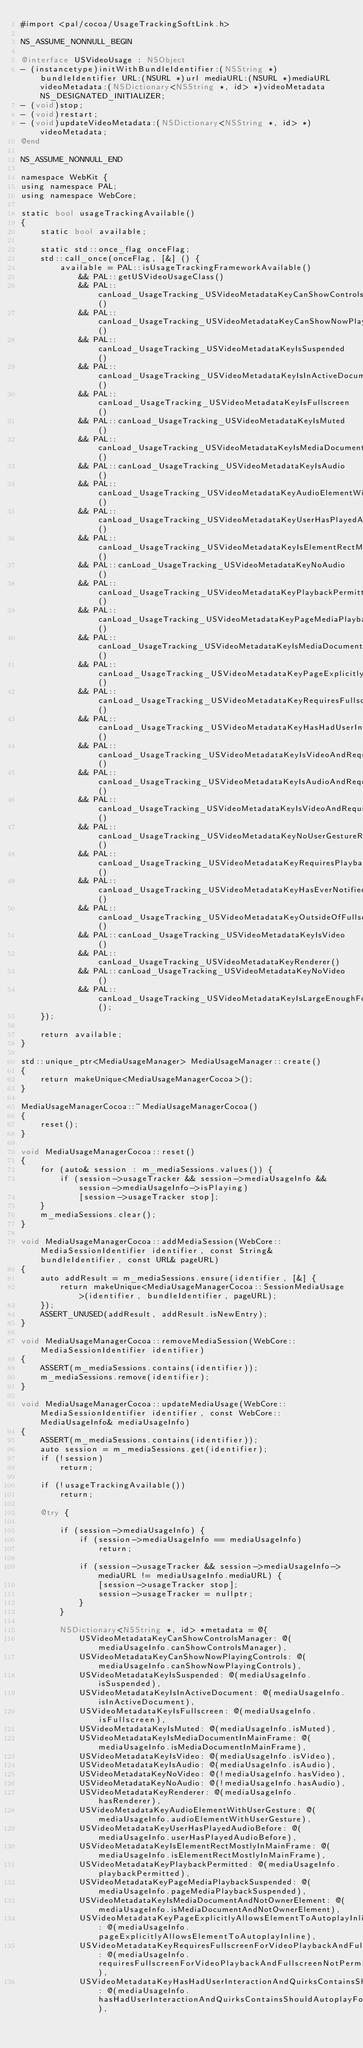<code> <loc_0><loc_0><loc_500><loc_500><_ObjectiveC_>#import <pal/cocoa/UsageTrackingSoftLink.h>

NS_ASSUME_NONNULL_BEGIN

@interface USVideoUsage : NSObject
- (instancetype)initWithBundleIdentifier:(NSString *)bundleIdentifier URL:(NSURL *)url mediaURL:(NSURL *)mediaURL videoMetadata:(NSDictionary<NSString *, id> *)videoMetadata NS_DESIGNATED_INITIALIZER;
- (void)stop;
- (void)restart;
- (void)updateVideoMetadata:(NSDictionary<NSString *, id> *)videoMetadata;
@end

NS_ASSUME_NONNULL_END

namespace WebKit {
using namespace PAL;
using namespace WebCore;

static bool usageTrackingAvailable()
{
    static bool available;

    static std::once_flag onceFlag;
    std::call_once(onceFlag, [&] () {
        available = PAL::isUsageTrackingFrameworkAvailable()
            && PAL::getUSVideoUsageClass()
            && PAL::canLoad_UsageTracking_USVideoMetadataKeyCanShowControlsManager()
            && PAL::canLoad_UsageTracking_USVideoMetadataKeyCanShowNowPlayingControls()
            && PAL::canLoad_UsageTracking_USVideoMetadataKeyIsSuspended()
            && PAL::canLoad_UsageTracking_USVideoMetadataKeyIsInActiveDocument()
            && PAL::canLoad_UsageTracking_USVideoMetadataKeyIsFullscreen()
            && PAL::canLoad_UsageTracking_USVideoMetadataKeyIsMuted()
            && PAL::canLoad_UsageTracking_USVideoMetadataKeyIsMediaDocumentInMainFrame()
            && PAL::canLoad_UsageTracking_USVideoMetadataKeyIsAudio()
            && PAL::canLoad_UsageTracking_USVideoMetadataKeyAudioElementWithUserGesture()
            && PAL::canLoad_UsageTracking_USVideoMetadataKeyUserHasPlayedAudioBefore()
            && PAL::canLoad_UsageTracking_USVideoMetadataKeyIsElementRectMostlyInMainFrame()
            && PAL::canLoad_UsageTracking_USVideoMetadataKeyNoAudio()
            && PAL::canLoad_UsageTracking_USVideoMetadataKeyPlaybackPermitted()
            && PAL::canLoad_UsageTracking_USVideoMetadataKeyPageMediaPlaybackSuspended()
            && PAL::canLoad_UsageTracking_USVideoMetadataKeyIsMediaDocumentAndNotOwnerElement()
            && PAL::canLoad_UsageTracking_USVideoMetadataKeyPageExplicitlyAllowsElementToAutoplayInline()
            && PAL::canLoad_UsageTracking_USVideoMetadataKeyRequiresFullscreenForVideoPlaybackAndFullscreenNotPermitted()
            && PAL::canLoad_UsageTracking_USVideoMetadataKeyHasHadUserInteractionAndQuirksContainsShouldAutoplayForArbitraryUserGesture()
            && PAL::canLoad_UsageTracking_USVideoMetadataKeyIsVideoAndRequiresUserGestureForVideoRateChange()
            && PAL::canLoad_UsageTracking_USVideoMetadataKeyIsAudioAndRequiresUserGestureForAudioRateChange()
            && PAL::canLoad_UsageTracking_USVideoMetadataKeyIsVideoAndRequiresUserGestureForVideoDueToLowPowerMode()
            && PAL::canLoad_UsageTracking_USVideoMetadataKeyNoUserGestureRequired()
            && PAL::canLoad_UsageTracking_USVideoMetadataKeyRequiresPlaybackAndIsNotPlaying()
            && PAL::canLoad_UsageTracking_USVideoMetadataKeyHasEverNotifiedAboutPlaying()
            && PAL::canLoad_UsageTracking_USVideoMetadataKeyOutsideOfFullscreen()
            && PAL::canLoad_UsageTracking_USVideoMetadataKeyIsVideo()
            && PAL::canLoad_UsageTracking_USVideoMetadataKeyRenderer()
            && PAL::canLoad_UsageTracking_USVideoMetadataKeyNoVideo()
            && PAL::canLoad_UsageTracking_USVideoMetadataKeyIsLargeEnoughForMainContent();
    });

    return available;
}

std::unique_ptr<MediaUsageManager> MediaUsageManager::create()
{
    return makeUnique<MediaUsageManagerCocoa>();
}

MediaUsageManagerCocoa::~MediaUsageManagerCocoa()
{
    reset();
}

void MediaUsageManagerCocoa::reset()
{
    for (auto& session : m_mediaSessions.values()) {
        if (session->usageTracker && session->mediaUsageInfo && session->mediaUsageInfo->isPlaying)
            [session->usageTracker stop];
    }
    m_mediaSessions.clear();
}

void MediaUsageManagerCocoa::addMediaSession(WebCore::MediaSessionIdentifier identifier, const String& bundleIdentifier, const URL& pageURL)
{
    auto addResult = m_mediaSessions.ensure(identifier, [&] {
        return makeUnique<MediaUsageManagerCocoa::SessionMediaUsage>(identifier, bundleIdentifier, pageURL);
    });
    ASSERT_UNUSED(addResult, addResult.isNewEntry);
}

void MediaUsageManagerCocoa::removeMediaSession(WebCore::MediaSessionIdentifier identifier)
{
    ASSERT(m_mediaSessions.contains(identifier));
    m_mediaSessions.remove(identifier);
}

void MediaUsageManagerCocoa::updateMediaUsage(WebCore::MediaSessionIdentifier identifier, const WebCore::MediaUsageInfo& mediaUsageInfo)
{
    ASSERT(m_mediaSessions.contains(identifier));
    auto session = m_mediaSessions.get(identifier);
    if (!session)
        return;

    if (!usageTrackingAvailable())
        return;

    @try {

        if (session->mediaUsageInfo) {
            if (session->mediaUsageInfo == mediaUsageInfo)
                return;

            if (session->usageTracker && session->mediaUsageInfo->mediaURL != mediaUsageInfo.mediaURL) {
                [session->usageTracker stop];
                session->usageTracker = nullptr;
            }
        }

        NSDictionary<NSString *, id> *metadata = @{
            USVideoMetadataKeyCanShowControlsManager: @(mediaUsageInfo.canShowControlsManager),
            USVideoMetadataKeyCanShowNowPlayingControls: @(mediaUsageInfo.canShowNowPlayingControls),
            USVideoMetadataKeyIsSuspended: @(mediaUsageInfo.isSuspended),
            USVideoMetadataKeyIsInActiveDocument: @(mediaUsageInfo.isInActiveDocument),
            USVideoMetadataKeyIsFullscreen: @(mediaUsageInfo.isFullscreen),
            USVideoMetadataKeyIsMuted: @(mediaUsageInfo.isMuted),
            USVideoMetadataKeyIsMediaDocumentInMainFrame: @(mediaUsageInfo.isMediaDocumentInMainFrame),
            USVideoMetadataKeyIsVideo: @(mediaUsageInfo.isVideo),
            USVideoMetadataKeyIsAudio: @(mediaUsageInfo.isAudio),
            USVideoMetadataKeyNoVideo: @(!mediaUsageInfo.hasVideo),
            USVideoMetadataKeyNoAudio: @(!mediaUsageInfo.hasAudio),
            USVideoMetadataKeyRenderer: @(mediaUsageInfo.hasRenderer),
            USVideoMetadataKeyAudioElementWithUserGesture: @(mediaUsageInfo.audioElementWithUserGesture),
            USVideoMetadataKeyUserHasPlayedAudioBefore: @(mediaUsageInfo.userHasPlayedAudioBefore),
            USVideoMetadataKeyIsElementRectMostlyInMainFrame: @(mediaUsageInfo.isElementRectMostlyInMainFrame),
            USVideoMetadataKeyPlaybackPermitted: @(mediaUsageInfo.playbackPermitted),
            USVideoMetadataKeyPageMediaPlaybackSuspended: @(mediaUsageInfo.pageMediaPlaybackSuspended),
            USVideoMetadataKeyIsMediaDocumentAndNotOwnerElement: @(mediaUsageInfo.isMediaDocumentAndNotOwnerElement),
            USVideoMetadataKeyPageExplicitlyAllowsElementToAutoplayInline: @(mediaUsageInfo.pageExplicitlyAllowsElementToAutoplayInline),
            USVideoMetadataKeyRequiresFullscreenForVideoPlaybackAndFullscreenNotPermitted: @(mediaUsageInfo.requiresFullscreenForVideoPlaybackAndFullscreenNotPermitted),
            USVideoMetadataKeyHasHadUserInteractionAndQuirksContainsShouldAutoplayForArbitraryUserGesture: @(mediaUsageInfo.hasHadUserInteractionAndQuirksContainsShouldAutoplayForArbitraryUserGesture),</code> 